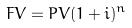<formula> <loc_0><loc_0><loc_500><loc_500>F V = P V ( 1 + i ) ^ { n }</formula> 